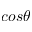<formula> <loc_0><loc_0><loc_500><loc_500>\cos \theta</formula> 